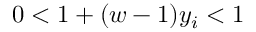<formula> <loc_0><loc_0><loc_500><loc_500>0 < 1 + ( w - 1 ) y _ { i } < 1</formula> 